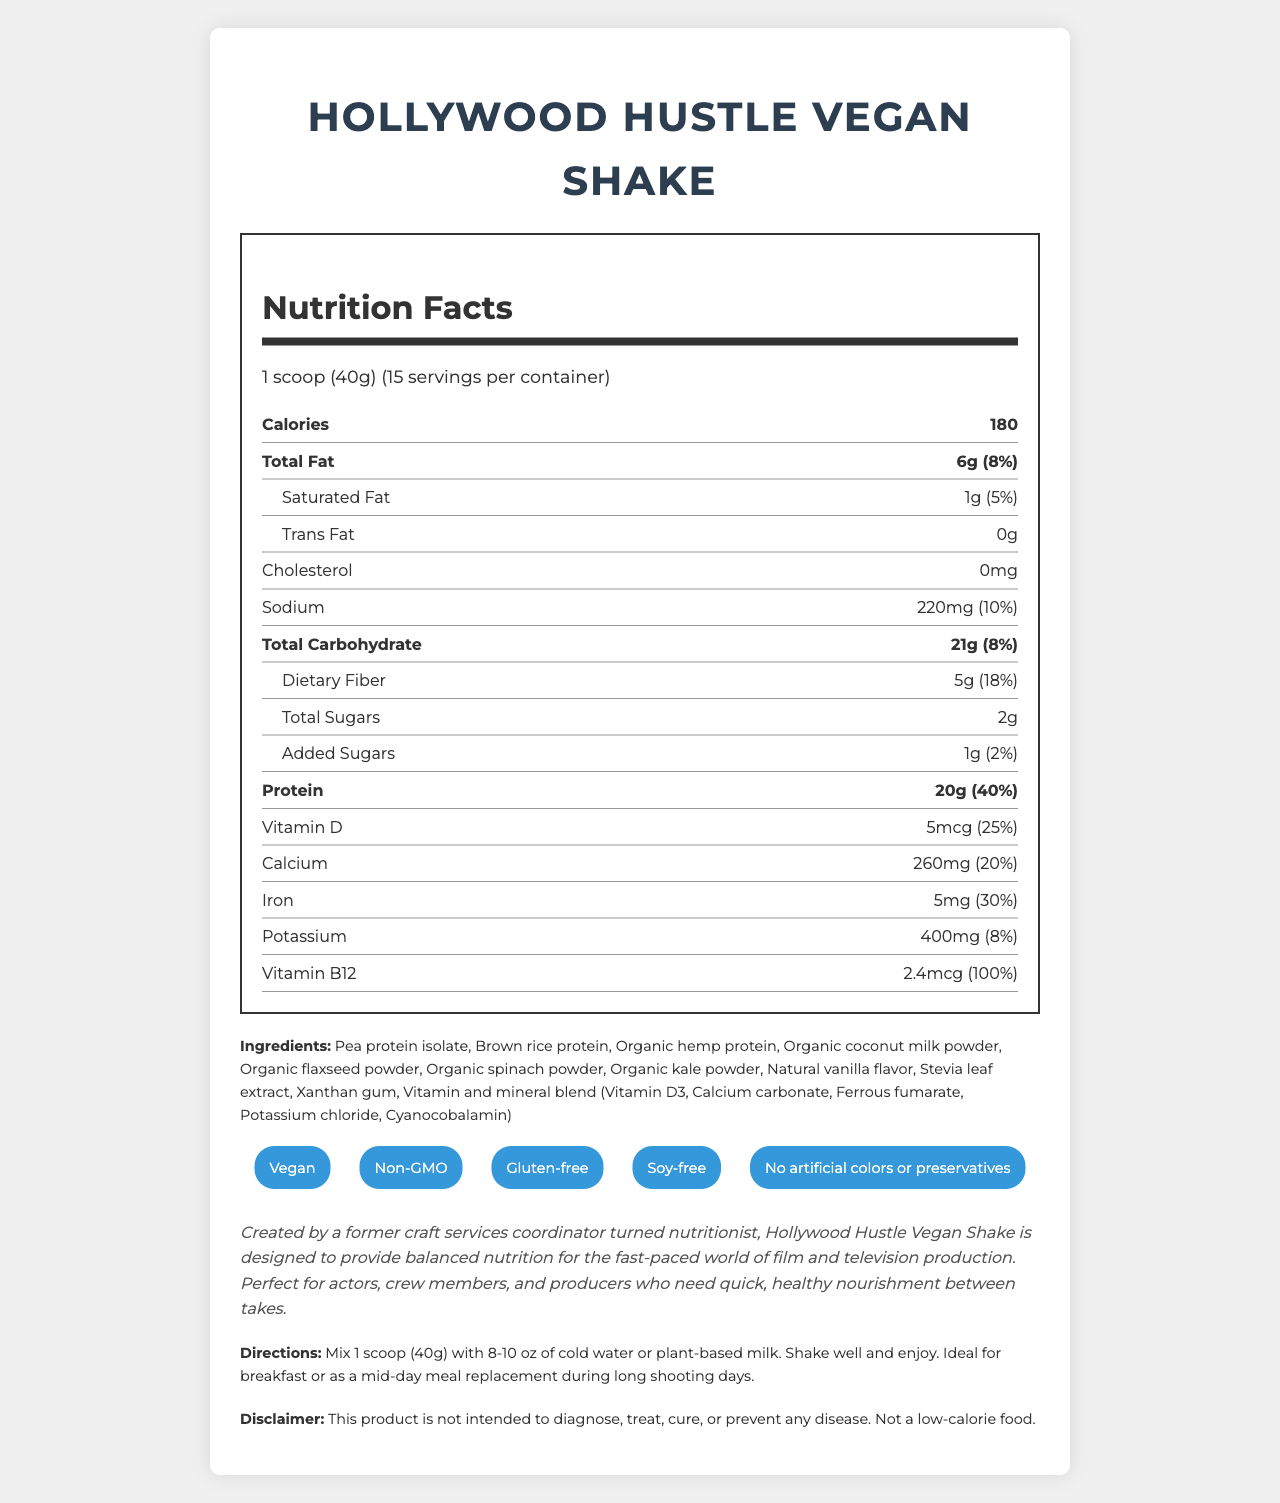What is the serving size for Hollywood Hustle Vegan Shake? The serving size is explicitly stated in the nutrition facts.
Answer: 1 scoop (40g) How many calories are in one serving of Hollywood Hustle Vegan Shake? The number of calories per serving is mentioned in the nutrition facts section.
Answer: 180 calories How much protein is in one serving, and what percentage of the daily value does it cover? The protein content and its percentage of the daily value are specified in the nutrition information.
Answer: 20g, 40% What is the total amount of sugars in each serving? The total sugar content per serving is listed in the nutrition facts.
Answer: 2g Is the product suitable for someone with a soy allergy? The allergen information states that the product is produced in a facility that also processes soy.
Answer: No, it is produced in a facility that processes soy. How many servings are there in one container? A. 10 B. 15 C. 20 D. 25 The number of servings per container is specified in the nutrition facts.
Answer: B. 15 Which ingredient is not present in Hollywood Hustle Vegan Shake? A. Pea protein isolate B. Brown rice protein C. Whey protein D. Organic coconut milk powder The ingredient list does not mention whey protein.
Answer: C. Whey protein Is the product non-GMO and gluten-free? The special features list includes both "Non-GMO" and "Gluten-free."
Answer: Yes What is the amount of dietary fiber in one serving and its percentage of the daily value? The dietary fiber content and its daily value percentage are provided in the nutrition facts.
Answer: 5g, 18% Who created the Hollywood Hustle Vegan Shake? The brand story mentions the creator's background.
Answer: A former craft services coordinator turned nutritionist Summarize the main idea of the document. The document primarily focuses on the nutritional content, ingredients, and special features of the product, emphasizing its suitability for busy film and TV professionals.
Answer: The document provides detailed nutrition facts, ingredients, special features, and brand story for Hollywood Hustle Vegan Shake, a plant-based meal replacement designed for the demanding schedules of the film and television industry. What is the founder's favorite flavor? The document does not mention the founder's favorite flavor.
Answer: Not enough information 